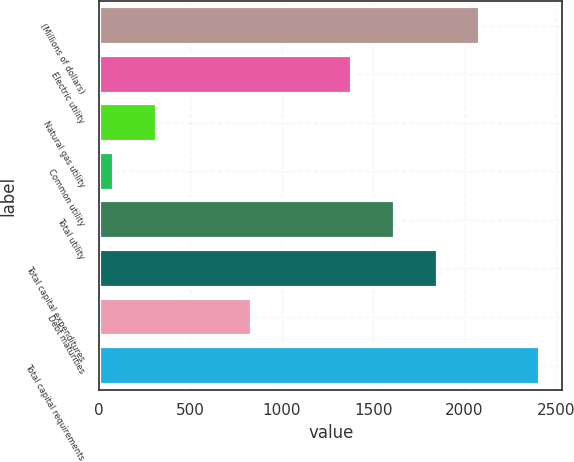Convert chart to OTSL. <chart><loc_0><loc_0><loc_500><loc_500><bar_chart><fcel>(Millions of dollars)<fcel>Electric utility<fcel>Natural gas utility<fcel>Common utility<fcel>Total utility<fcel>Total capital expenditures<fcel>Debt maturities<fcel>Total capital requirements<nl><fcel>2085.3<fcel>1386<fcel>317.1<fcel>84<fcel>1619.1<fcel>1852.2<fcel>835<fcel>2415<nl></chart> 